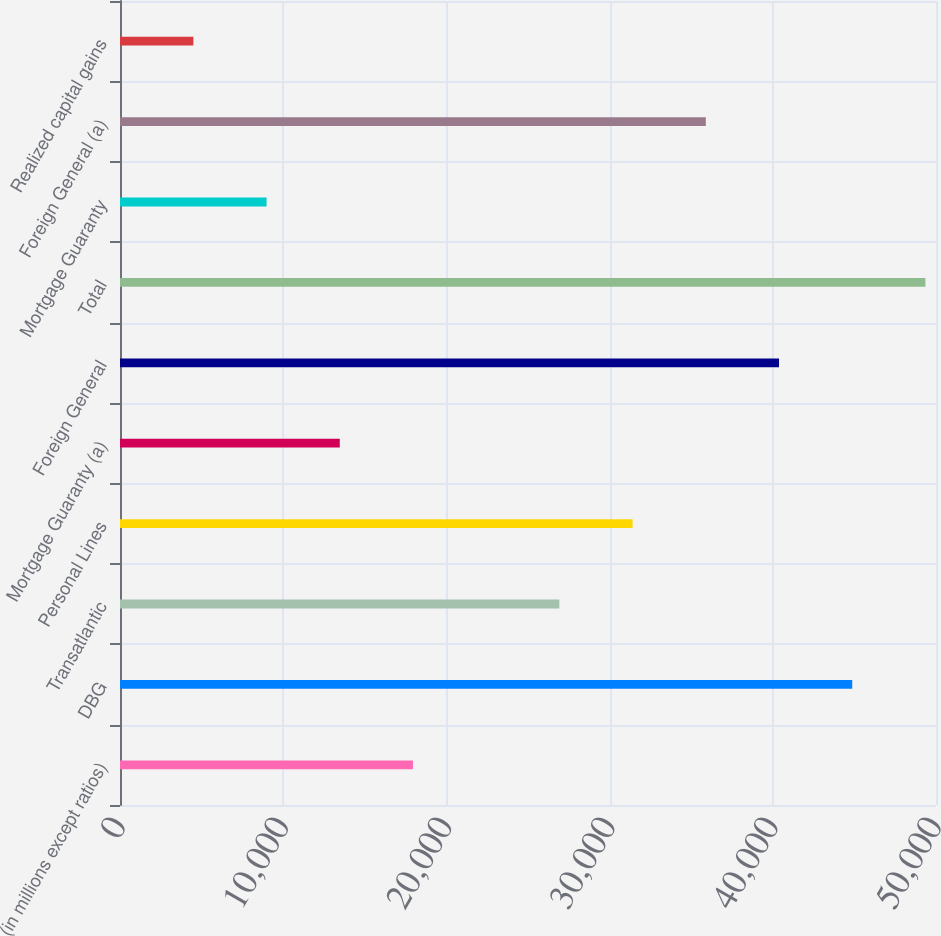Convert chart to OTSL. <chart><loc_0><loc_0><loc_500><loc_500><bar_chart><fcel>(in millions except ratios)<fcel>DBG<fcel>Transatlantic<fcel>Personal Lines<fcel>Mortgage Guaranty (a)<fcel>Foreign General<fcel>Total<fcel>Mortgage Guaranty<fcel>Foreign General (a)<fcel>Realized capital gains<nl><fcel>17952.4<fcel>44866<fcel>26923.6<fcel>31409.2<fcel>13466.8<fcel>40380.4<fcel>49351.6<fcel>8981.2<fcel>35894.8<fcel>4495.6<nl></chart> 